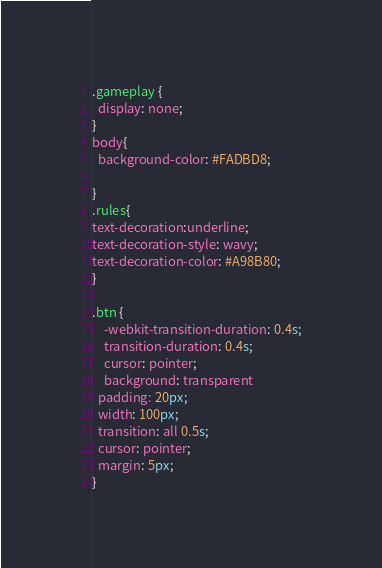Convert code to text. <code><loc_0><loc_0><loc_500><loc_500><_CSS_>.gameplay {
  display: none;
}
body{
  background-color: #FADBD8;

}
.rules{
text-decoration:underline;
text-decoration-style: wavy;
text-decoration-color: #A98B80;
}

.btn {
    -webkit-transition-duration: 0.4s;
    transition-duration: 0.4s;
    cursor: pointer;
    background: transparent
  padding: 20px;
  width: 100px;
  transition: all 0.5s;
  cursor: pointer;
  margin: 5px;
}
</code> 